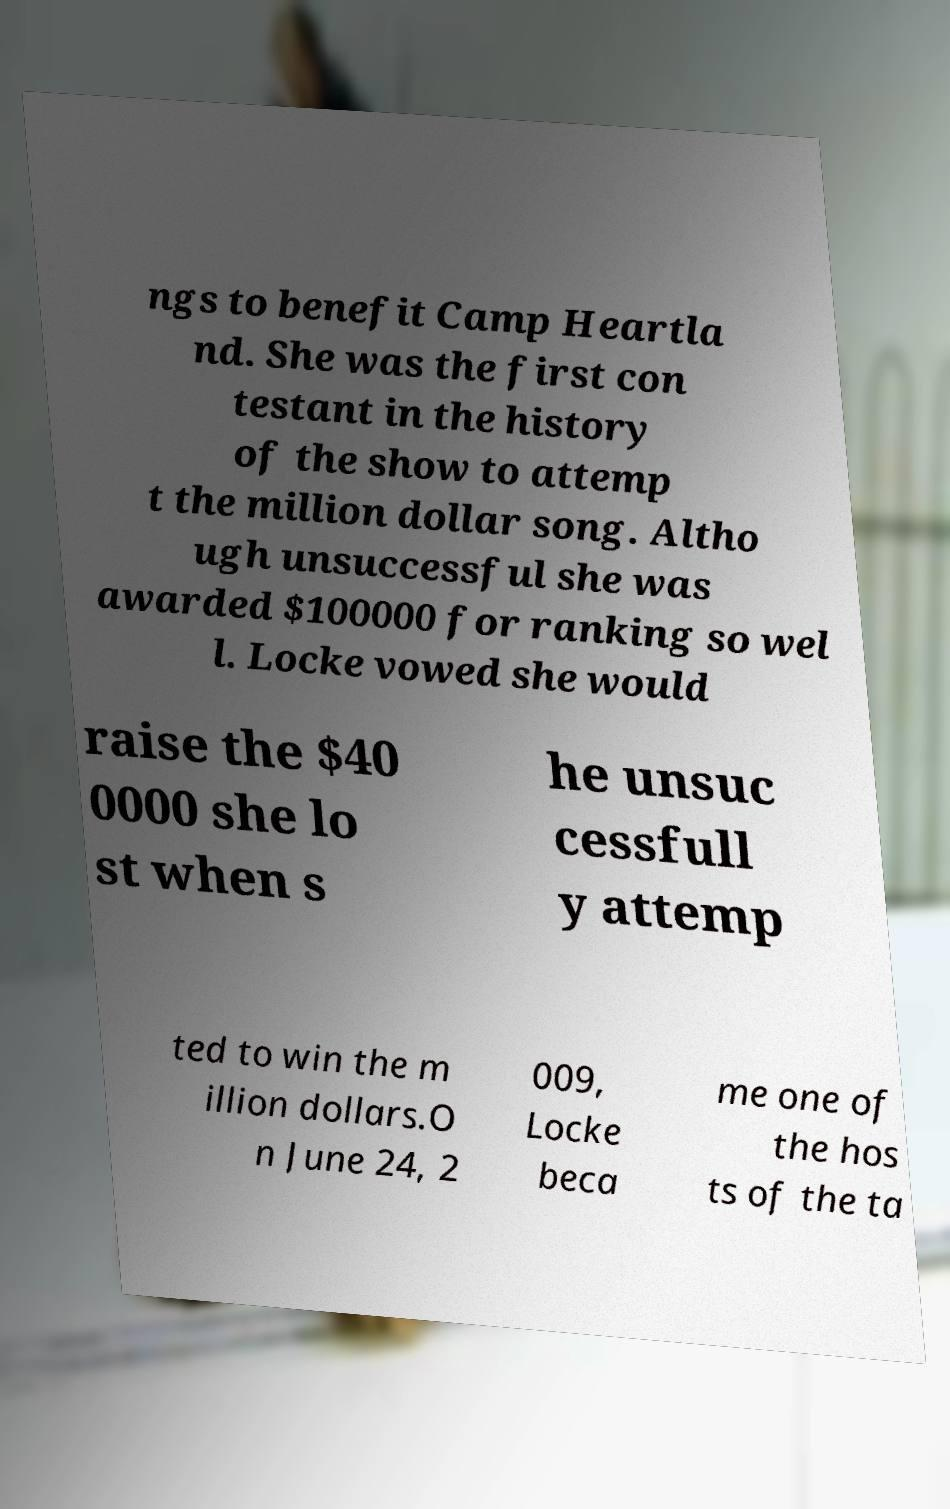Please read and relay the text visible in this image. What does it say? ngs to benefit Camp Heartla nd. She was the first con testant in the history of the show to attemp t the million dollar song. Altho ugh unsuccessful she was awarded $100000 for ranking so wel l. Locke vowed she would raise the $40 0000 she lo st when s he unsuc cessfull y attemp ted to win the m illion dollars.O n June 24, 2 009, Locke beca me one of the hos ts of the ta 